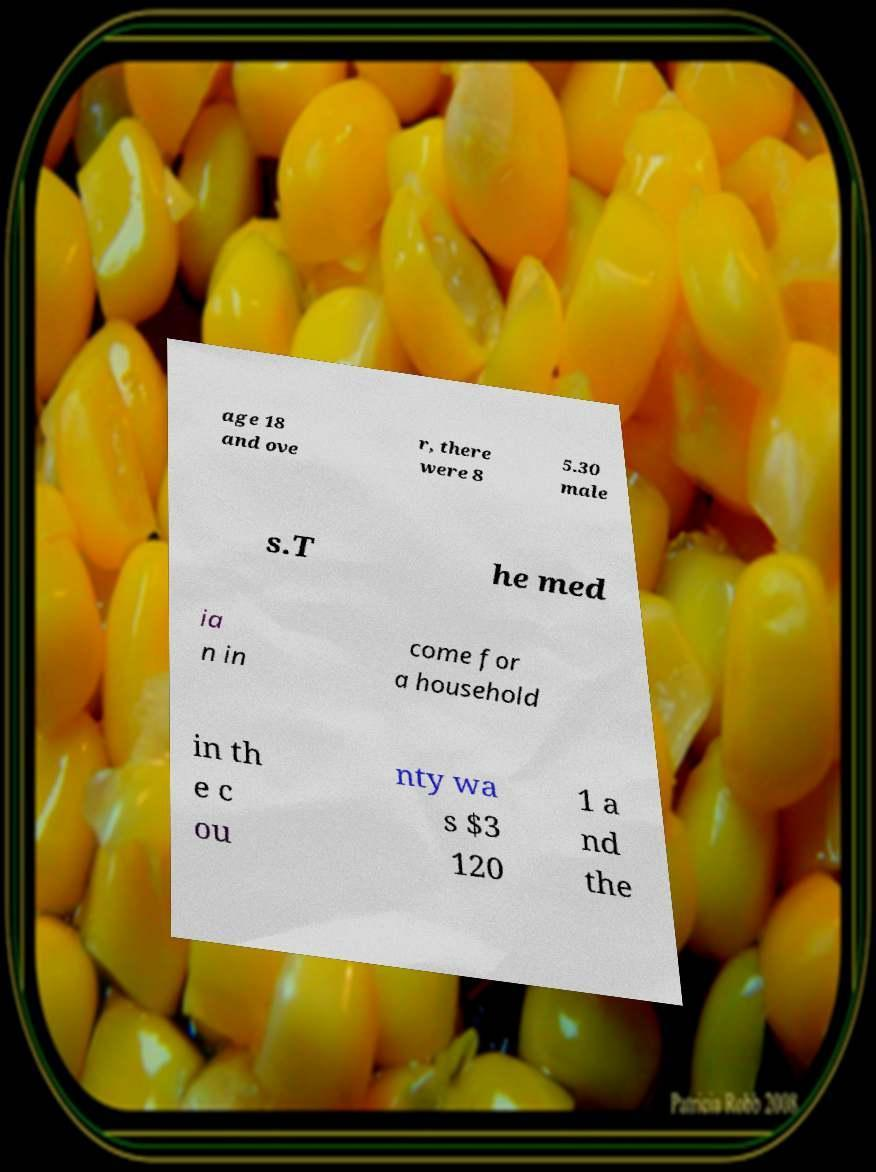What messages or text are displayed in this image? I need them in a readable, typed format. age 18 and ove r, there were 8 5.30 male s.T he med ia n in come for a household in th e c ou nty wa s $3 120 1 a nd the 